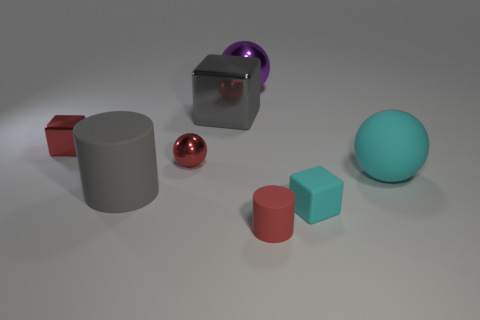Is the material of the big purple sphere that is to the right of the big rubber cylinder the same as the big cylinder?
Your answer should be very brief. No. Is the number of large gray things in front of the red matte cylinder the same as the number of large cyan matte spheres?
Your answer should be compact. No. What is the size of the red rubber cylinder?
Your answer should be compact. Small. What material is the tiny cube that is the same color as the small matte cylinder?
Provide a succinct answer. Metal. How many large shiny blocks are the same color as the small sphere?
Make the answer very short. 0. Do the cyan sphere and the red metallic cube have the same size?
Give a very brief answer. No. What is the size of the ball that is to the right of the metal object behind the large metallic block?
Provide a short and direct response. Large. Is the color of the big cylinder the same as the cube to the right of the gray cube?
Your response must be concise. No. Is there a cyan thing that has the same size as the purple metallic object?
Make the answer very short. Yes. There is a red rubber object that is on the right side of the gray matte cylinder; what size is it?
Ensure brevity in your answer.  Small. 